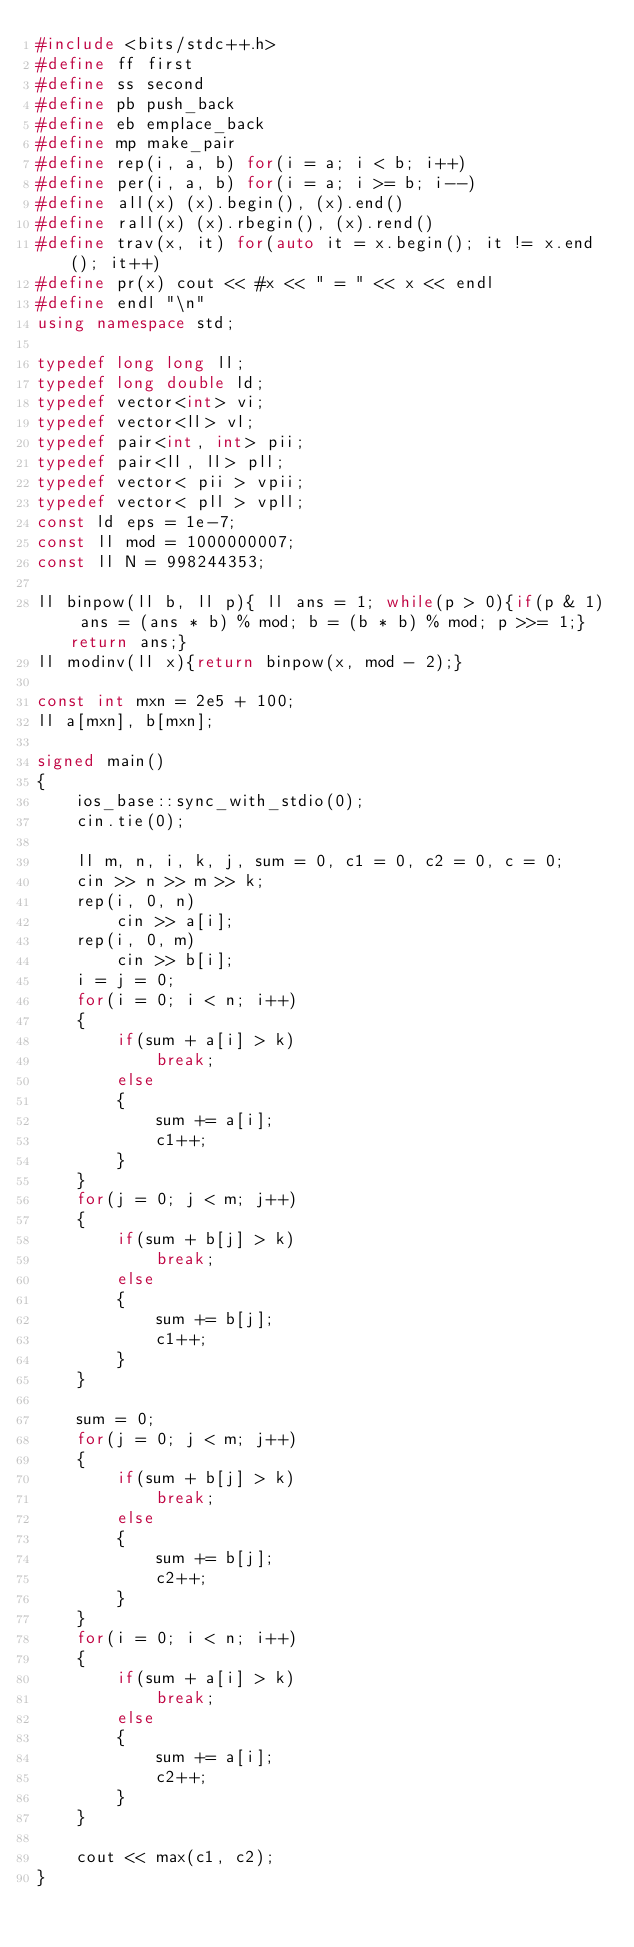Convert code to text. <code><loc_0><loc_0><loc_500><loc_500><_C++_>#include <bits/stdc++.h>
#define ff first
#define ss second
#define pb push_back
#define eb emplace_back
#define mp make_pair
#define rep(i, a, b) for(i = a; i < b; i++)
#define per(i, a, b) for(i = a; i >= b; i--)
#define all(x) (x).begin(), (x).end()
#define rall(x) (x).rbegin(), (x).rend()
#define trav(x, it) for(auto it = x.begin(); it != x.end(); it++)
#define pr(x) cout << #x << " = " << x << endl
#define endl "\n"
using namespace std;

typedef long long ll;
typedef long double ld;
typedef vector<int> vi;
typedef vector<ll> vl;
typedef pair<int, int> pii;
typedef pair<ll, ll> pll;
typedef vector< pii > vpii;
typedef vector< pll > vpll;
const ld eps = 1e-7;
const ll mod = 1000000007;
const ll N = 998244353;

ll binpow(ll b, ll p){ ll ans = 1; while(p > 0){if(p & 1) ans = (ans * b) % mod; b = (b * b) % mod; p >>= 1;}return ans;}
ll modinv(ll x){return binpow(x, mod - 2);}

const int mxn = 2e5 + 100;
ll a[mxn], b[mxn];

signed main()
{
	ios_base::sync_with_stdio(0);
	cin.tie(0);

	ll m, n, i, k, j, sum = 0, c1 = 0, c2 = 0, c = 0;
	cin >> n >> m >> k;
	rep(i, 0, n)
		cin >> a[i];
	rep(i, 0, m)
		cin >> b[i];
	i = j = 0;
	for(i = 0; i < n; i++)
	{
		if(sum + a[i] > k)
			break;
		else
		{
			sum += a[i];
			c1++;
		}
	}
	for(j = 0; j < m; j++)
	{
		if(sum + b[j] > k)
			break;
		else
		{
			sum += b[j];
			c1++;
		}
	}

	sum = 0;
	for(j = 0; j < m; j++)
	{
		if(sum + b[j] > k)
			break;
		else
		{
			sum += b[j];
			c2++;
		}
	}
	for(i = 0; i < n; i++)
	{
		if(sum + a[i] > k)
			break;
		else
		{
			sum += a[i];
			c2++;
		}
	}

	cout << max(c1, c2);
}</code> 